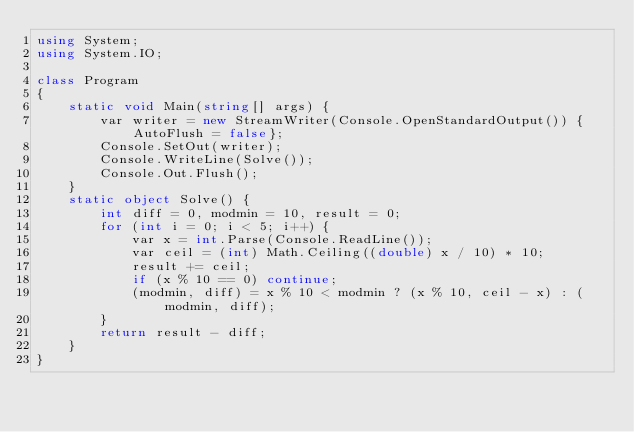Convert code to text. <code><loc_0><loc_0><loc_500><loc_500><_C#_>using System;
using System.IO;

class Program
{
    static void Main(string[] args) {
        var writer = new StreamWriter(Console.OpenStandardOutput()) {AutoFlush = false};
        Console.SetOut(writer);
        Console.WriteLine(Solve());
        Console.Out.Flush();
    }
    static object Solve() {
        int diff = 0, modmin = 10, result = 0;
        for (int i = 0; i < 5; i++) {
            var x = int.Parse(Console.ReadLine());
            var ceil = (int) Math.Ceiling((double) x / 10) * 10;
            result += ceil;
            if (x % 10 == 0) continue;
            (modmin, diff) = x % 10 < modmin ? (x % 10, ceil - x) : (modmin, diff);
        }
        return result - diff;
    }
}</code> 